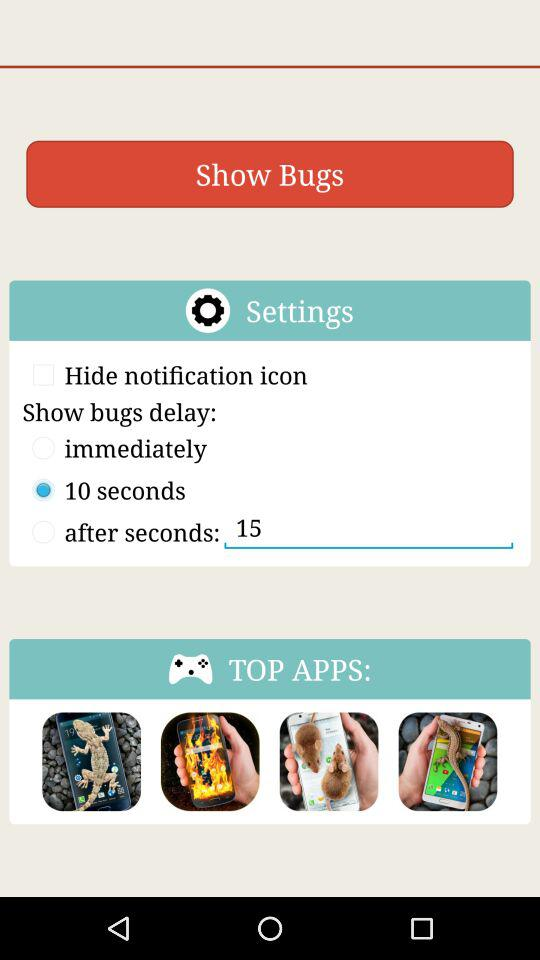For how many seconds does the notification get hidden? The notification gets hidden in 10 seconds. 